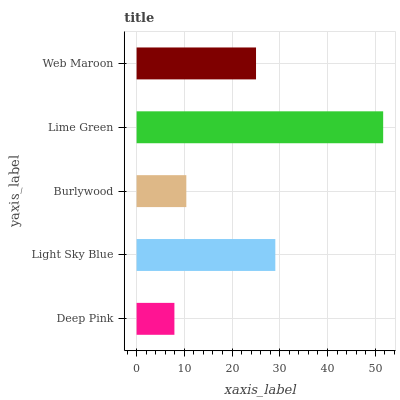Is Deep Pink the minimum?
Answer yes or no. Yes. Is Lime Green the maximum?
Answer yes or no. Yes. Is Light Sky Blue the minimum?
Answer yes or no. No. Is Light Sky Blue the maximum?
Answer yes or no. No. Is Light Sky Blue greater than Deep Pink?
Answer yes or no. Yes. Is Deep Pink less than Light Sky Blue?
Answer yes or no. Yes. Is Deep Pink greater than Light Sky Blue?
Answer yes or no. No. Is Light Sky Blue less than Deep Pink?
Answer yes or no. No. Is Web Maroon the high median?
Answer yes or no. Yes. Is Web Maroon the low median?
Answer yes or no. Yes. Is Deep Pink the high median?
Answer yes or no. No. Is Light Sky Blue the low median?
Answer yes or no. No. 